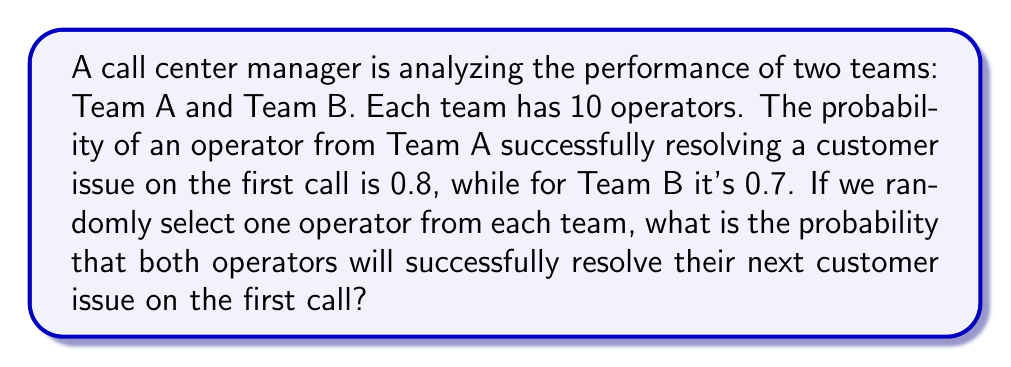Can you solve this math problem? To solve this problem, we need to use the concept of independent events and multiplication rule of probability.

1. Let's define our events:
   - Event A: An operator from Team A successfully resolves a customer issue on the first call
   - Event B: An operator from Team B successfully resolves a customer issue on the first call

2. We are given the following probabilities:
   $P(A) = 0.8$
   $P(B) = 0.7$

3. We want to find the probability of both events occurring together. Since the operators are selected independently from each team, these events are independent.

4. For independent events, the probability of both events occurring is the product of their individual probabilities:

   $P(A \text{ and } B) = P(A) \times P(B)$

5. Substituting the values:

   $P(A \text{ and } B) = 0.8 \times 0.7$

6. Calculating the result:

   $P(A \text{ and } B) = 0.56$

Therefore, the probability that both randomly selected operators will successfully resolve their next customer issue on the first call is 0.56 or 56%.
Answer: 0.56 or 56% 